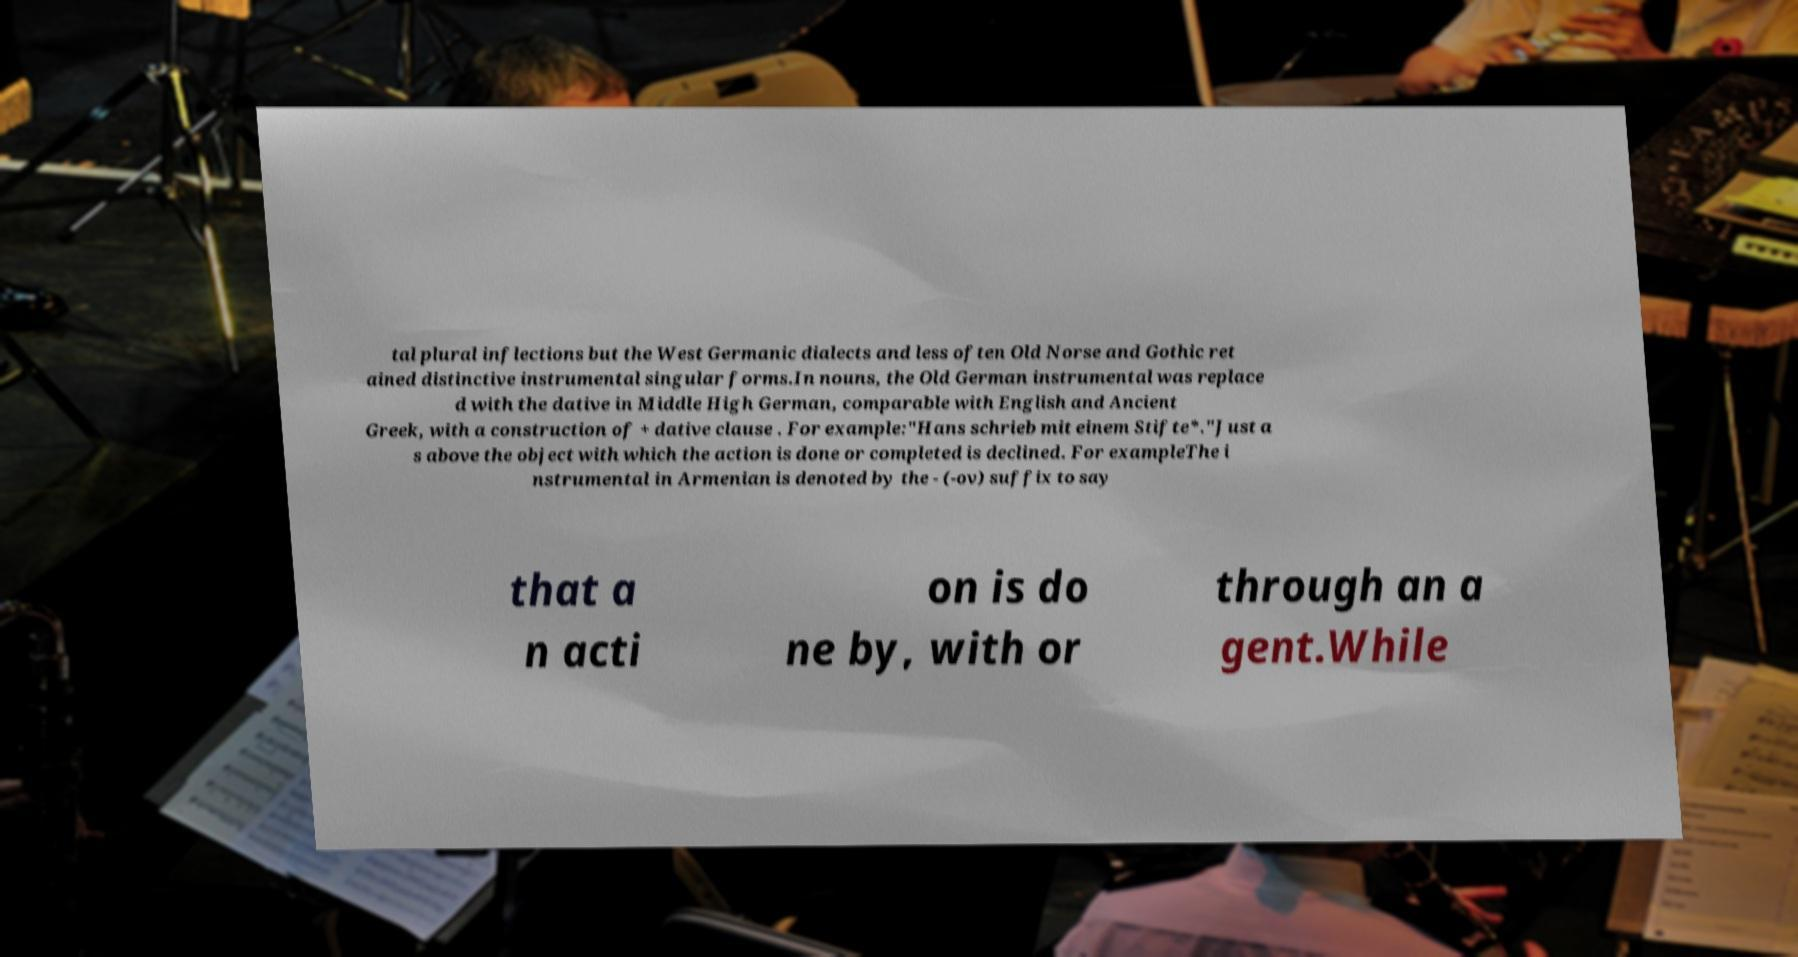I need the written content from this picture converted into text. Can you do that? tal plural inflections but the West Germanic dialects and less often Old Norse and Gothic ret ained distinctive instrumental singular forms.In nouns, the Old German instrumental was replace d with the dative in Middle High German, comparable with English and Ancient Greek, with a construction of + dative clause . For example:"Hans schrieb mit einem Stifte*."Just a s above the object with which the action is done or completed is declined. For exampleThe i nstrumental in Armenian is denoted by the - (-ov) suffix to say that a n acti on is do ne by, with or through an a gent.While 